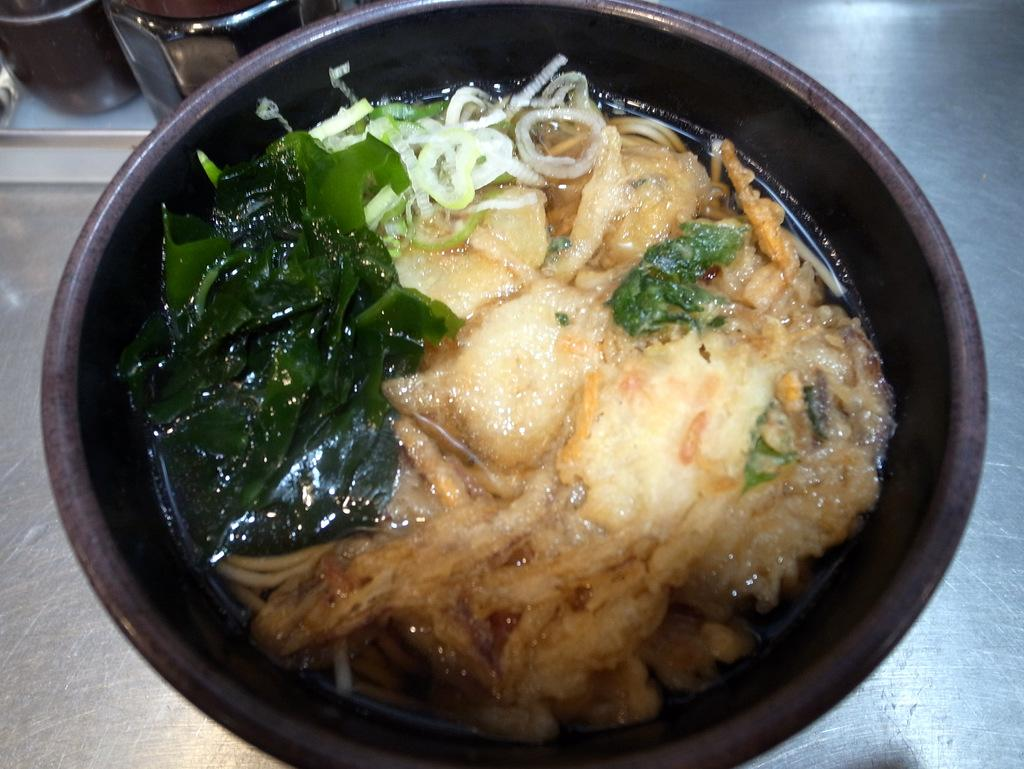What is the main object in the image? There is a pan in the image. What is inside the pan? There is a food item in the pan. What can be seen on the left side of the image? There are jars on the left side of the image. What is located at the bottom of the image? There is an iron object at the bottom of the image. What type of toothpaste is being used to cook the food in the pan? There is no toothpaste present in the image, and it is not being used to cook the food in the pan. What kind of produce is being stored in the jars on the left side of the image? There is no produce visible in the jars on the left side of the image. 